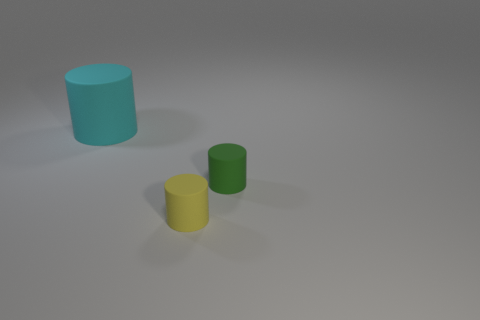There is another small object that is the same material as the tiny green thing; what is its color?
Give a very brief answer. Yellow. How big is the yellow thing?
Offer a terse response. Small. The green thing that is the same material as the yellow cylinder is what shape?
Provide a succinct answer. Cylinder. Are there fewer large rubber cylinders in front of the tiny green thing than tiny matte things?
Make the answer very short. Yes. What color is the thing that is right of the yellow cylinder?
Your answer should be compact. Green. Are there any other green objects that have the same shape as the small green matte object?
Provide a short and direct response. No. How many tiny yellow rubber things are the same shape as the green matte object?
Keep it short and to the point. 1. Is the number of yellow cylinders less than the number of cylinders?
Provide a short and direct response. Yes. There is a yellow matte cylinder to the left of the green object; is it the same size as the green thing?
Offer a terse response. Yes. Is the number of big cyan matte cylinders greater than the number of rubber objects?
Give a very brief answer. No. 